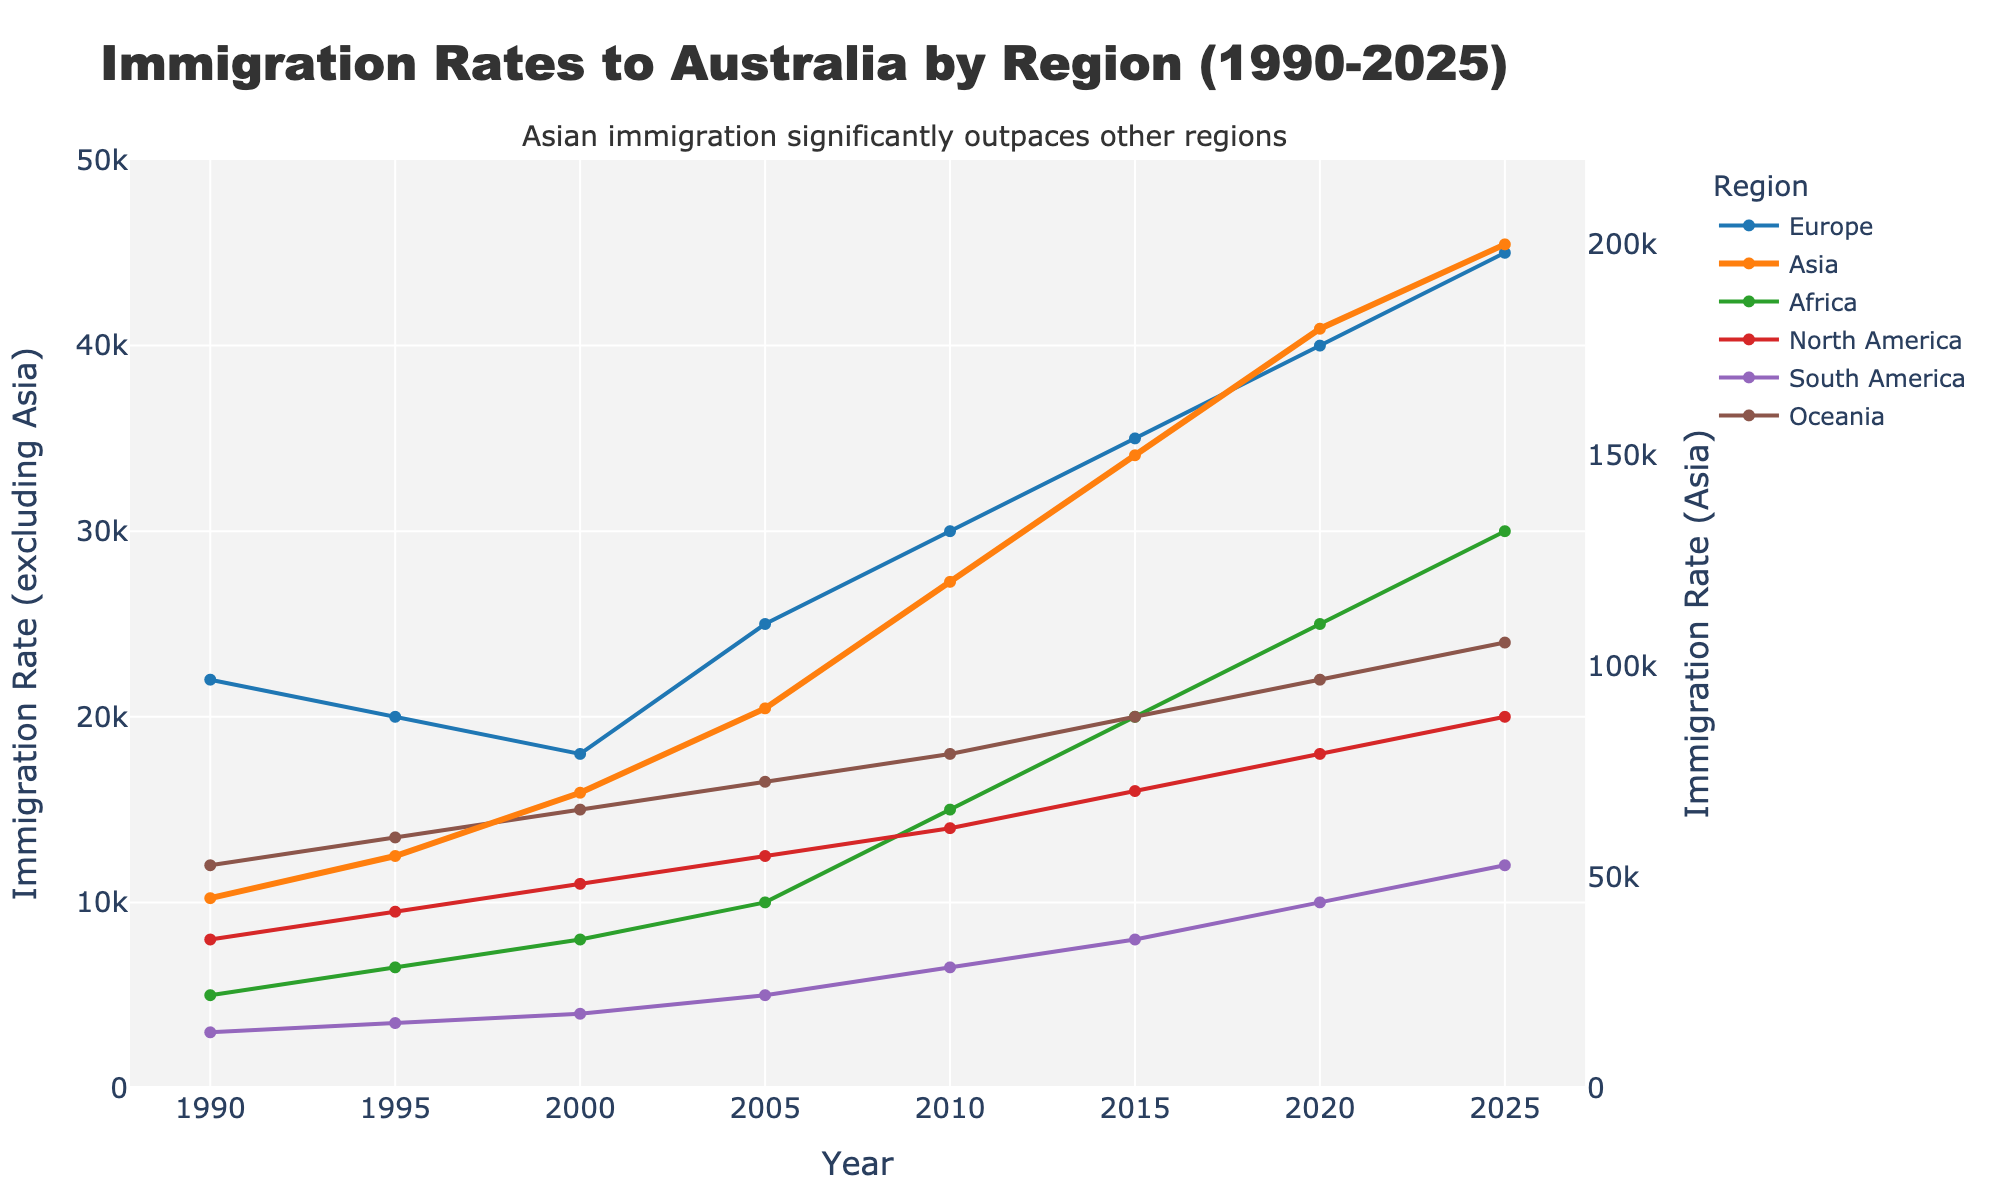What is the overall trend in immigration rates from Asia between 1990 and 2025? To find the overall trend, look at the line representing Asia from 1990 to 2025. The line consistently rises, indicating an overall increasing trend.
Answer: Increasing How does the immigration rate from Europe in 2000 compare to 2020? Compare the height of the line representing Europe at the points corresponding to the years 2000 and 2020. Immigration from Europe decreases from 18,000 in 2000 to 40,000 in 2020.
Answer: Lower in 2000 Which region had the highest immigration rate in 2015? Identify the region with the highest point on the chart in 2015. The tallest line in 2015 corresponds to Asia.
Answer: Asia What is the difference between the immigration rates of North America and South America in 2020? Locate the heights of the lines for North America and South America in 2020 and subtract the value of South America from North America (18,000 - 10,000).
Answer: 8,000 Which region has the least change in immigration rates from 1990 to 2025? Examine the lines for each region and determine which line is the flattest, indicating the least change. Oceania shows relatively smaller changes compared to others.
Answer: Oceania By how much did the immigration rate from Africa increase from 1990 to 2020? Look at the beginning (1990) and end (2020) points of the line for Africa and subtract the value in 1990 from the value in 2020 (25,000 - 5,000).
Answer: 20,000 Among Europe and North America, which region has a higher immigration rate in 2025? Compare the heights of the lines for Europe and North America in 2025. Europe has a higher value (45,000) than North America (20,000).
Answer: Europe In which year did South America first surpass an immigration rate of 5,000? Check the line for South America and identify when it first goes above 5,000. This occurs after 2000.
Answer: 2005 What is the ratio of the immigration rate from Asia to Europe in 2010? Divide the value for Asia by the value for Europe in 2010 (120,000 / 30,000).
Answer: 4 If you average the immigration rates from all regions in 2015, what do you get? Sum the immigration rates from all regions in 2015 (35,000 + 150,000 + 20,000 + 16,000 + 8,000 + 20,000) and divide by the number of regions (6). The sum is 249,000, and the average is 249,000 / 6.
Answer: 41,500 